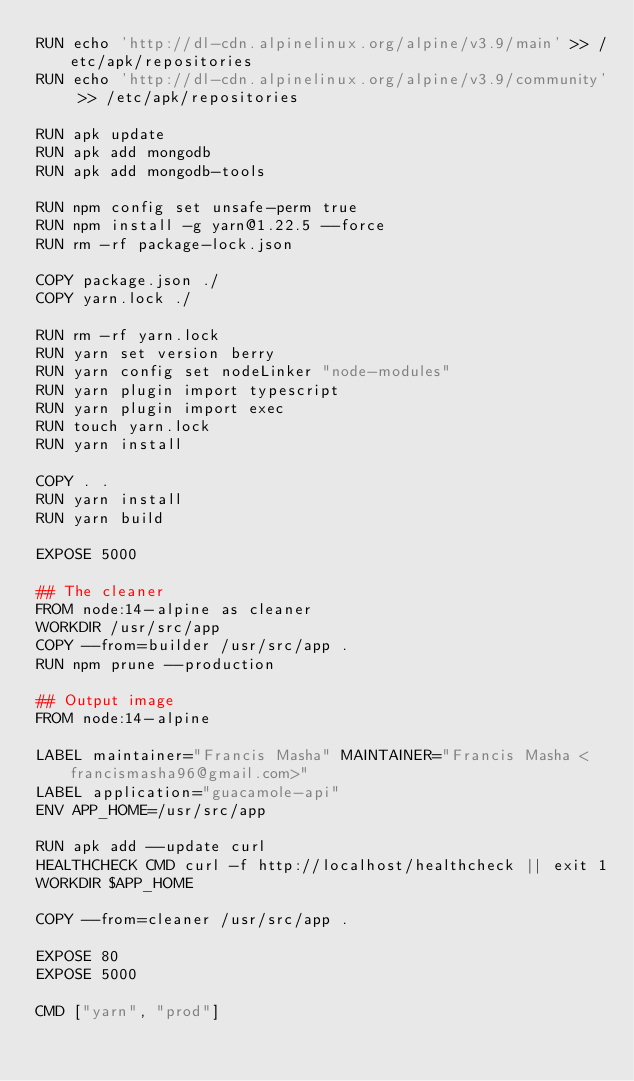<code> <loc_0><loc_0><loc_500><loc_500><_Dockerfile_>RUN echo 'http://dl-cdn.alpinelinux.org/alpine/v3.9/main' >> /etc/apk/repositories
RUN echo 'http://dl-cdn.alpinelinux.org/alpine/v3.9/community' >> /etc/apk/repositories

RUN apk update
RUN apk add mongodb
RUN apk add mongodb-tools

RUN npm config set unsafe-perm true
RUN npm install -g yarn@1.22.5 --force
RUN rm -rf package-lock.json

COPY package.json ./
COPY yarn.lock ./

RUN rm -rf yarn.lock
RUN yarn set version berry
RUN yarn config set nodeLinker "node-modules"
RUN yarn plugin import typescript
RUN yarn plugin import exec
RUN touch yarn.lock
RUN yarn install

COPY . .
RUN yarn install
RUN yarn build

EXPOSE 5000

## The cleaner
FROM node:14-alpine as cleaner
WORKDIR /usr/src/app
COPY --from=builder /usr/src/app .
RUN npm prune --production

## Output image
FROM node:14-alpine

LABEL maintainer="Francis Masha" MAINTAINER="Francis Masha <francismasha96@gmail.com>"
LABEL application="guacamole-api"
ENV APP_HOME=/usr/src/app

RUN apk add --update curl
HEALTHCHECK CMD curl -f http://localhost/healthcheck || exit 1
WORKDIR $APP_HOME

COPY --from=cleaner /usr/src/app .

EXPOSE 80
EXPOSE 5000

CMD ["yarn", "prod"]
</code> 